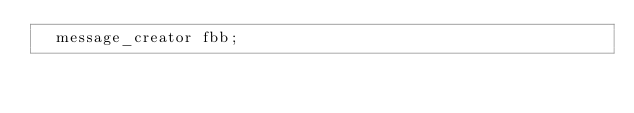<code> <loc_0><loc_0><loc_500><loc_500><_C++_>  message_creator fbb;</code> 